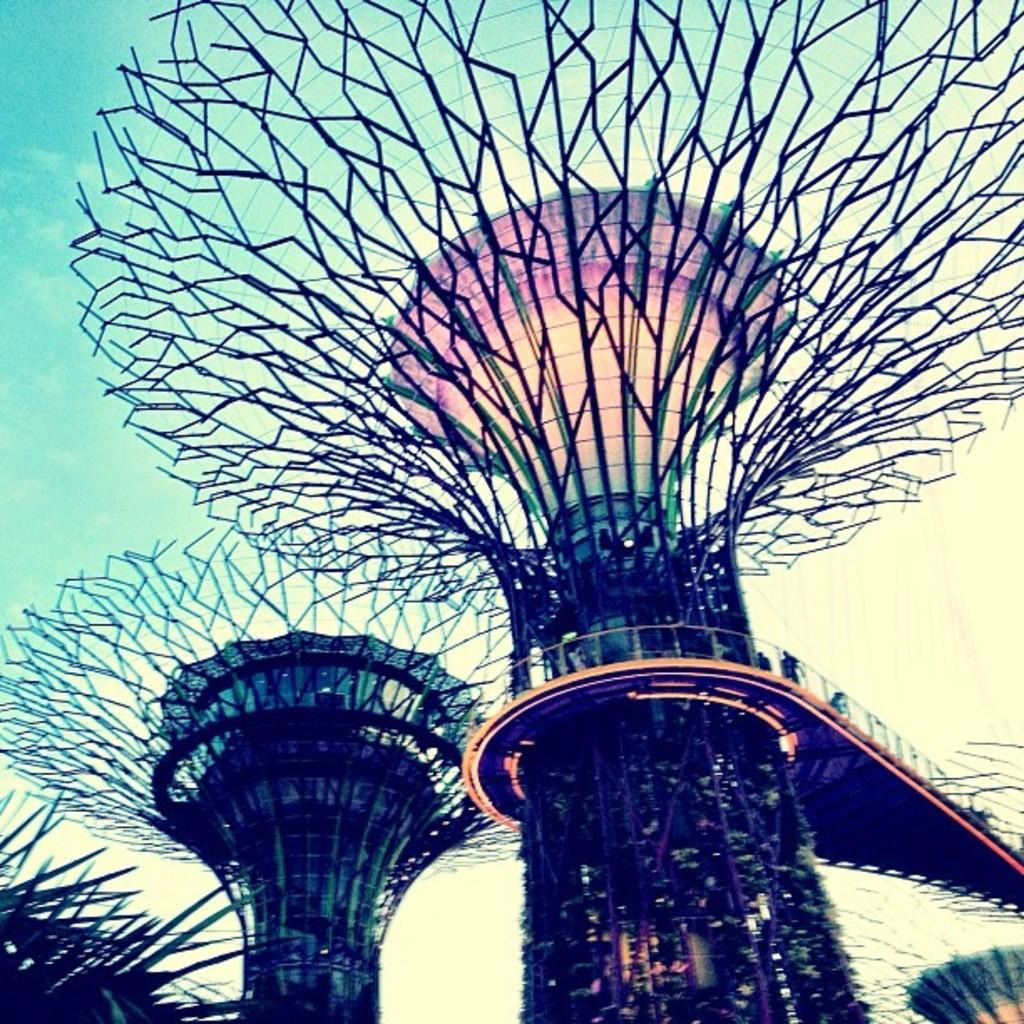What type of bridge is depicted in the image? There is a bridge of modern architecture in the image. What can be seen in the background of the image? The sky is visible in the image. How many roses are on the bridge in the image? There are no roses present on the bridge in the image. What type of yam is being used to support the bridge in the image? There is no yam being used to support the bridge in the image; it is a modern architectural structure. 